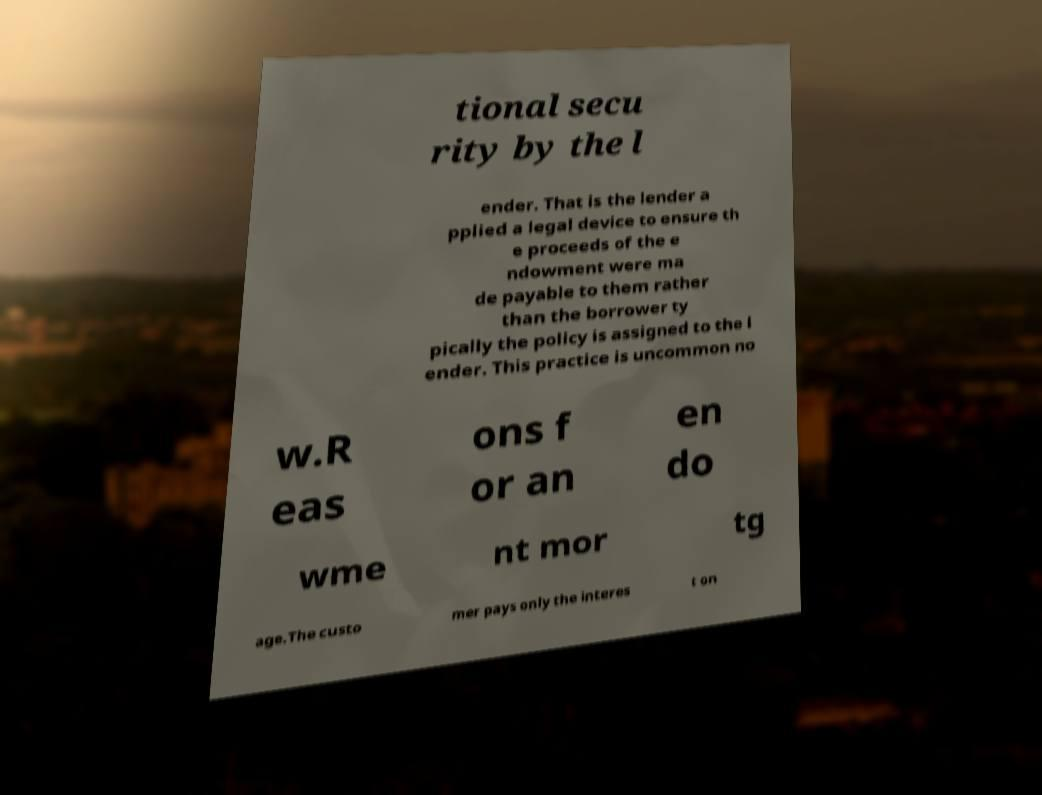I need the written content from this picture converted into text. Can you do that? tional secu rity by the l ender. That is the lender a pplied a legal device to ensure th e proceeds of the e ndowment were ma de payable to them rather than the borrower ty pically the policy is assigned to the l ender. This practice is uncommon no w.R eas ons f or an en do wme nt mor tg age.The custo mer pays only the interes t on 